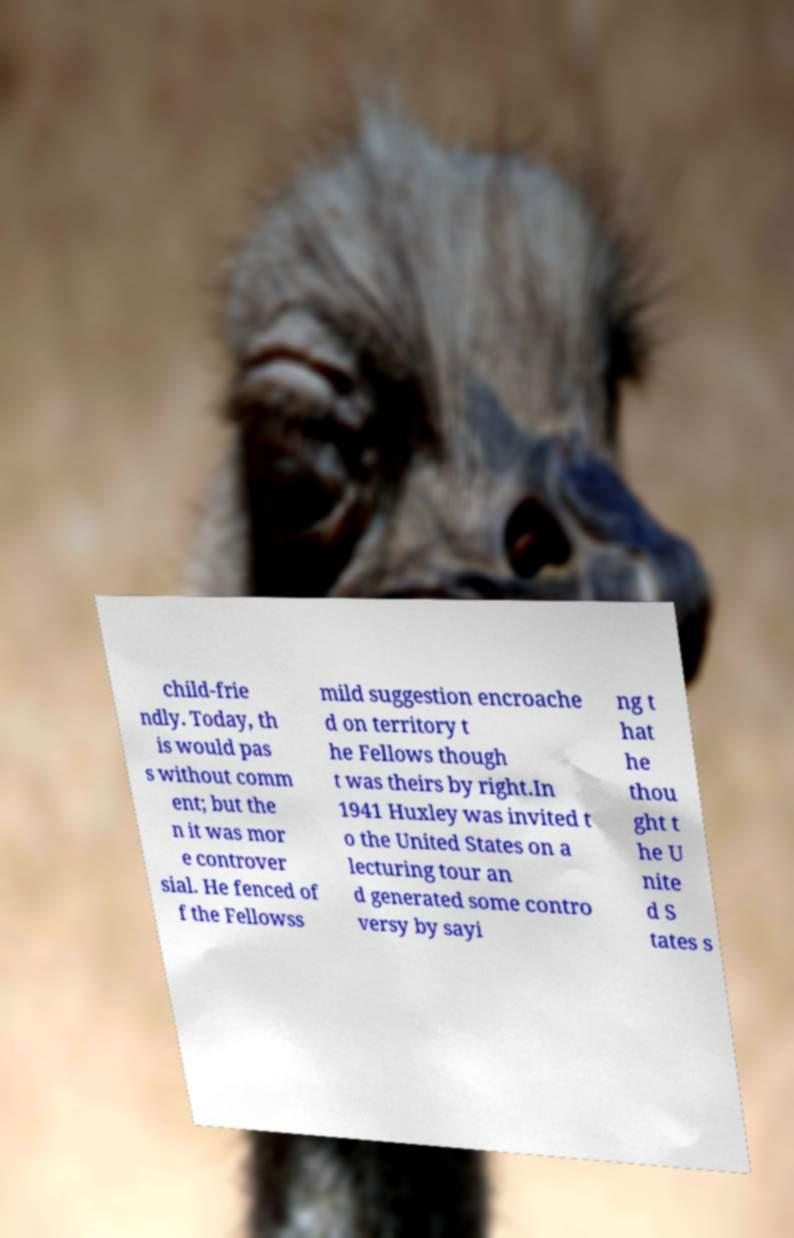Could you extract and type out the text from this image? child-frie ndly. Today, th is would pas s without comm ent; but the n it was mor e controver sial. He fenced of f the Fellowss mild suggestion encroache d on territory t he Fellows though t was theirs by right.In 1941 Huxley was invited t o the United States on a lecturing tour an d generated some contro versy by sayi ng t hat he thou ght t he U nite d S tates s 